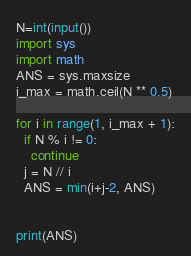<code> <loc_0><loc_0><loc_500><loc_500><_Python_>N=int(input())
import sys
import math
ANS = sys.maxsize
i_max = math.ceil(N ** 0.5)

for i in range(1, i_max + 1):
  if N % i != 0:
    continue
  j = N // i
  ANS = min(i+j-2, ANS)


print(ANS)</code> 